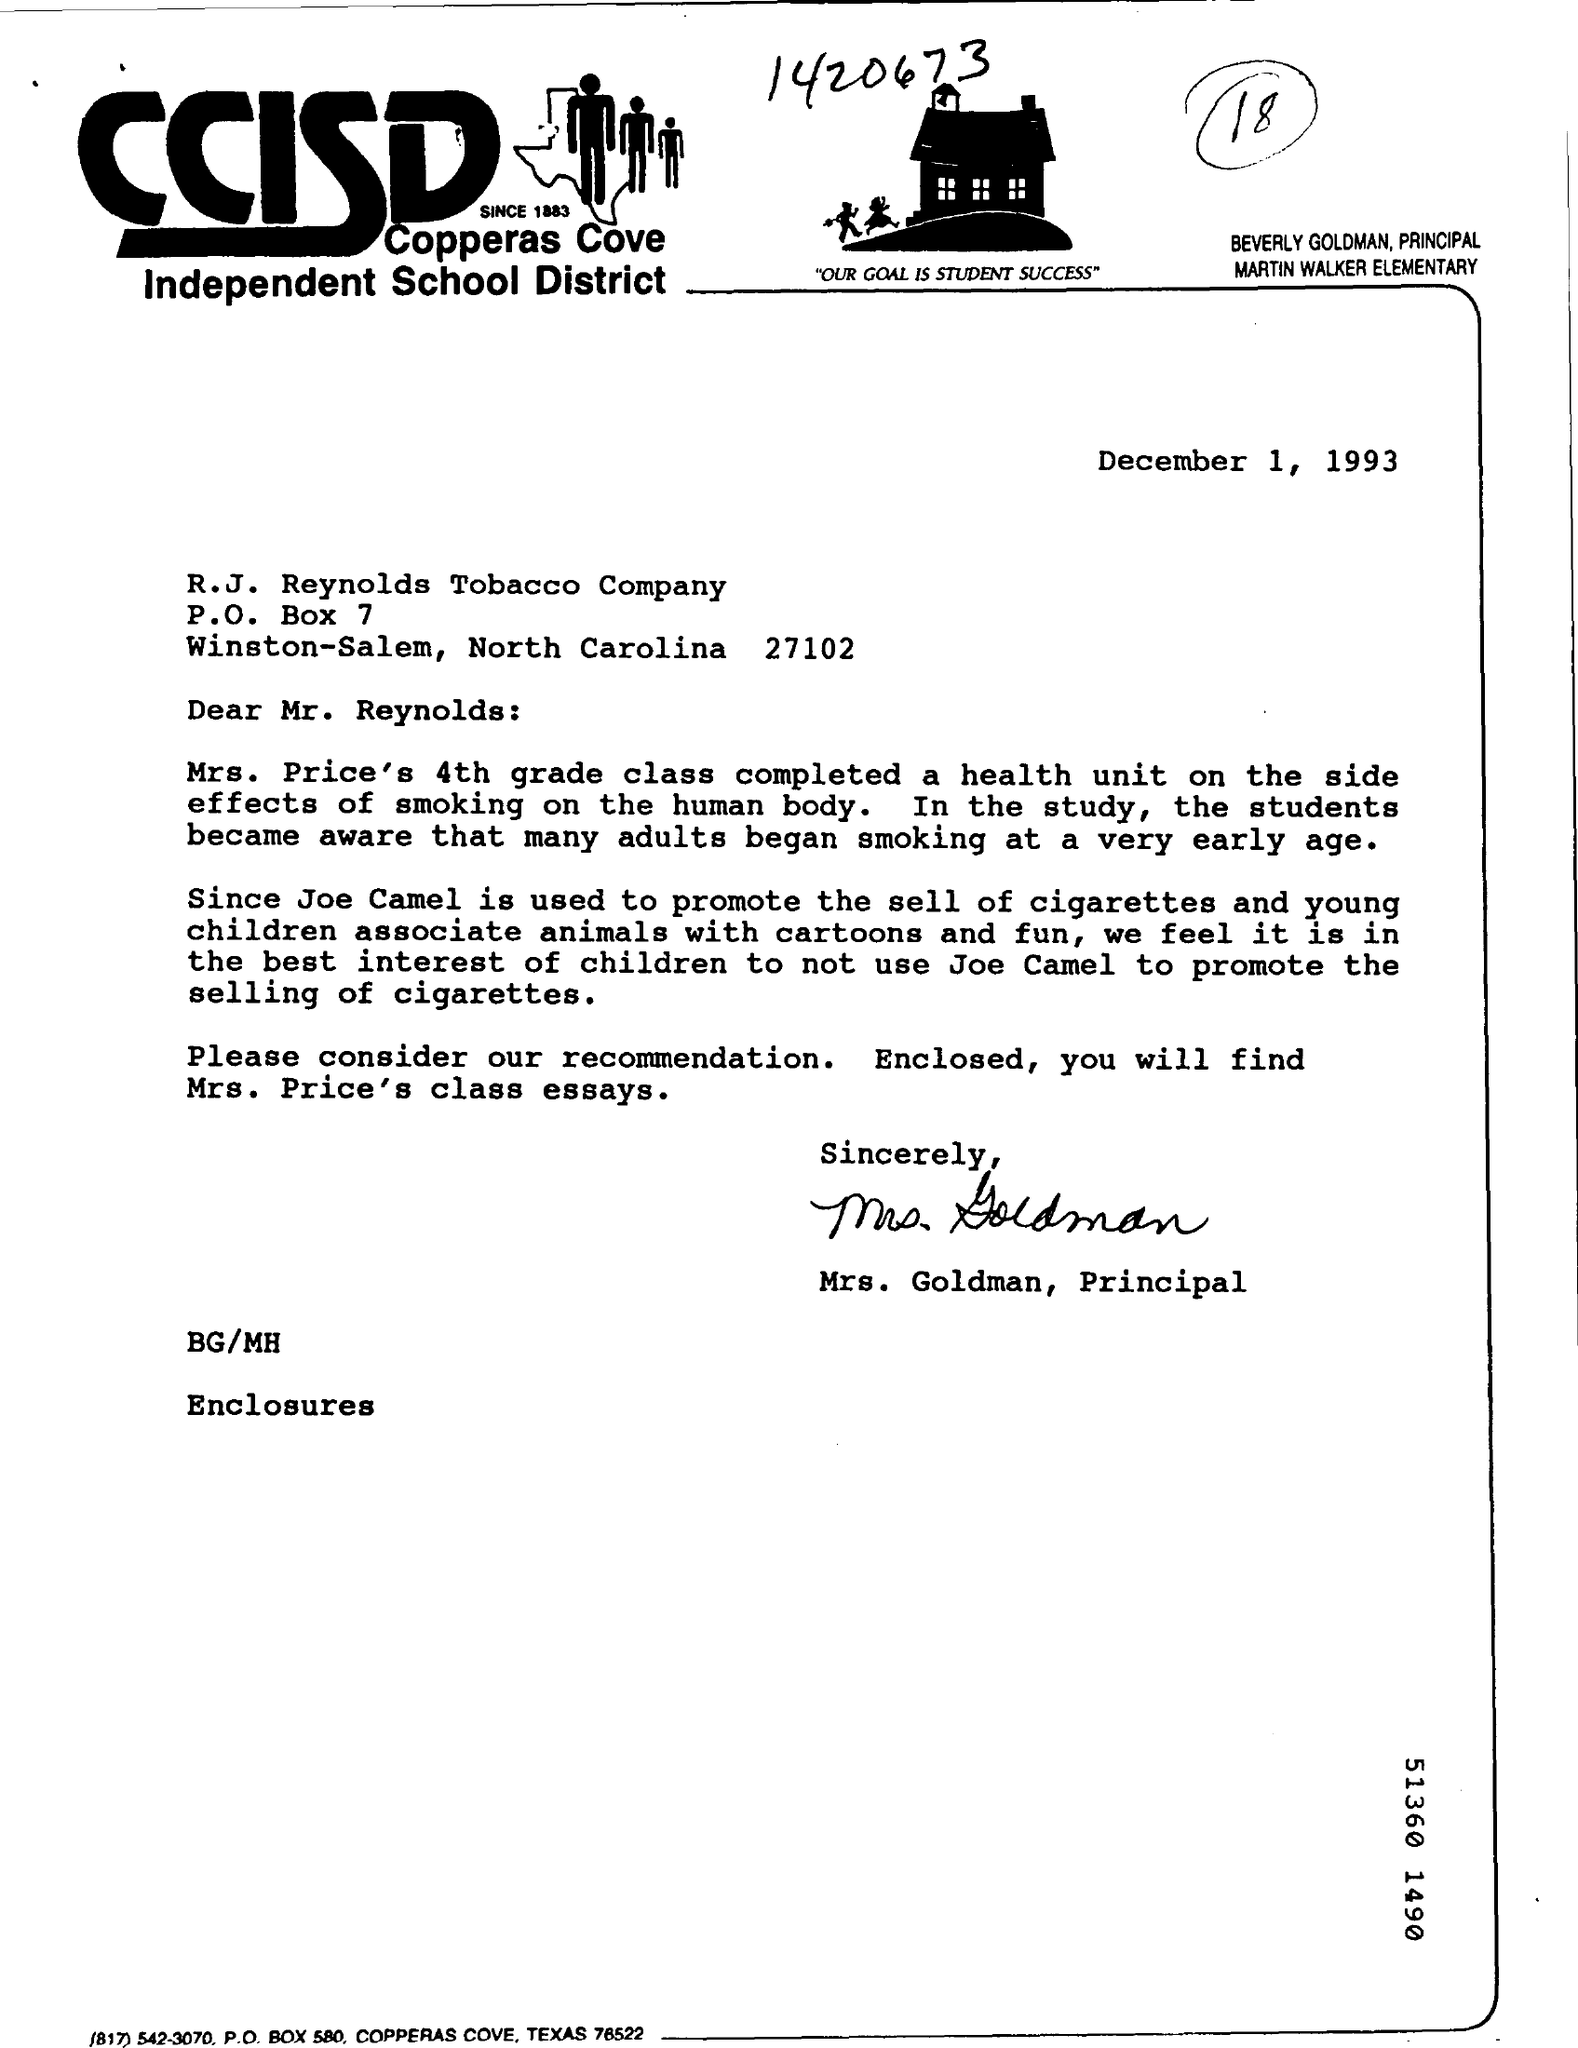What is the P.O Box Number ?
Provide a short and direct response. 7. What is the date mentioned in the top of the document ?
Give a very brief answer. December 1, 1993. What is the Fullform of CCISD ?
Your answer should be compact. Copperas Cove Independent School District. Which Number Round up on top of the document ?
Ensure brevity in your answer.  18. 